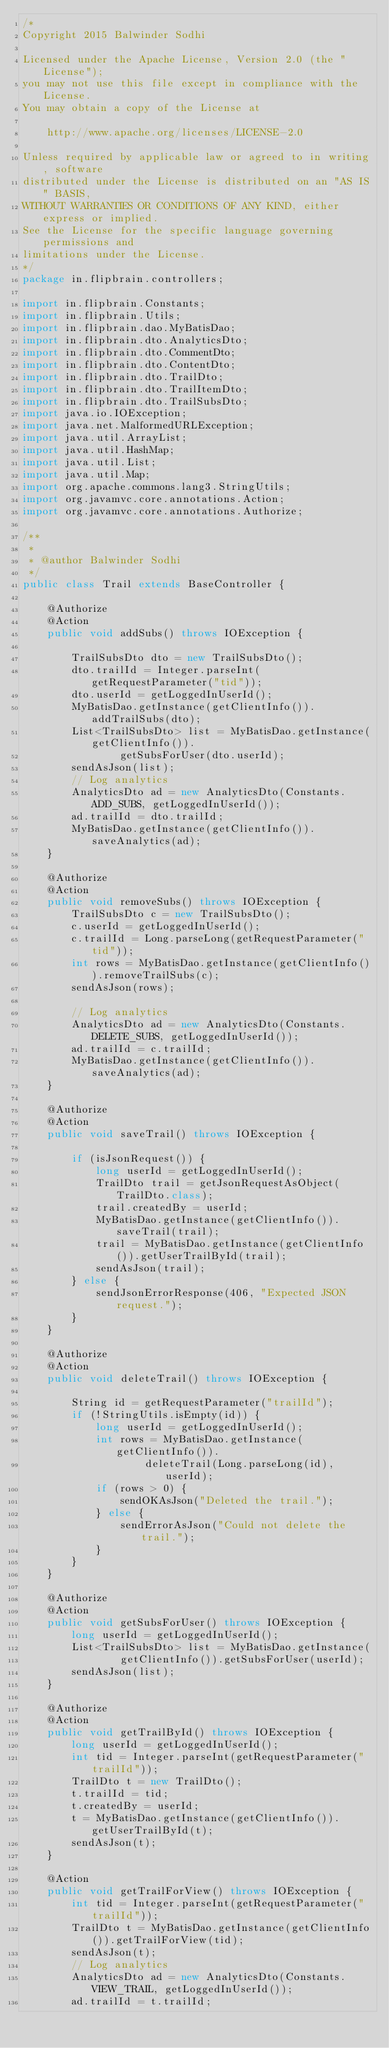<code> <loc_0><loc_0><loc_500><loc_500><_Java_>/*
Copyright 2015 Balwinder Sodhi

Licensed under the Apache License, Version 2.0 (the "License");
you may not use this file except in compliance with the License.
You may obtain a copy of the License at

    http://www.apache.org/licenses/LICENSE-2.0

Unless required by applicable law or agreed to in writing, software
distributed under the License is distributed on an "AS IS" BASIS,
WITHOUT WARRANTIES OR CONDITIONS OF ANY KIND, either express or implied.
See the License for the specific language governing permissions and
limitations under the License.
*/
package in.flipbrain.controllers;

import in.flipbrain.Constants;
import in.flipbrain.Utils;
import in.flipbrain.dao.MyBatisDao;
import in.flipbrain.dto.AnalyticsDto;
import in.flipbrain.dto.CommentDto;
import in.flipbrain.dto.ContentDto;
import in.flipbrain.dto.TrailDto;
import in.flipbrain.dto.TrailItemDto;
import in.flipbrain.dto.TrailSubsDto;
import java.io.IOException;
import java.net.MalformedURLException;
import java.util.ArrayList;
import java.util.HashMap;
import java.util.List;
import java.util.Map;
import org.apache.commons.lang3.StringUtils;
import org.javamvc.core.annotations.Action;
import org.javamvc.core.annotations.Authorize;

/**
 *
 * @author Balwinder Sodhi
 */
public class Trail extends BaseController {

    @Authorize
    @Action
    public void addSubs() throws IOException {

        TrailSubsDto dto = new TrailSubsDto();
        dto.trailId = Integer.parseInt(getRequestParameter("tid"));
        dto.userId = getLoggedInUserId();
        MyBatisDao.getInstance(getClientInfo()).addTrailSubs(dto);
        List<TrailSubsDto> list = MyBatisDao.getInstance(getClientInfo()).
                getSubsForUser(dto.userId);
        sendAsJson(list);
        // Log analytics
        AnalyticsDto ad = new AnalyticsDto(Constants.ADD_SUBS, getLoggedInUserId());
        ad.trailId = dto.trailId;
        MyBatisDao.getInstance(getClientInfo()).saveAnalytics(ad);
    }

    @Authorize
    @Action
    public void removeSubs() throws IOException {
        TrailSubsDto c = new TrailSubsDto();
        c.userId = getLoggedInUserId();
        c.trailId = Long.parseLong(getRequestParameter("tid"));
        int rows = MyBatisDao.getInstance(getClientInfo()).removeTrailSubs(c);
        sendAsJson(rows);

        // Log analytics
        AnalyticsDto ad = new AnalyticsDto(Constants.DELETE_SUBS, getLoggedInUserId());
        ad.trailId = c.trailId;
        MyBatisDao.getInstance(getClientInfo()).saveAnalytics(ad);
    }

    @Authorize
    @Action
    public void saveTrail() throws IOException {

        if (isJsonRequest()) {
            long userId = getLoggedInUserId();
            TrailDto trail = getJsonRequestAsObject(TrailDto.class);
            trail.createdBy = userId;
            MyBatisDao.getInstance(getClientInfo()).saveTrail(trail);
            trail = MyBatisDao.getInstance(getClientInfo()).getUserTrailById(trail);
            sendAsJson(trail);
        } else {
            sendJsonErrorResponse(406, "Expected JSON request.");
        }
    }

    @Authorize
    @Action
    public void deleteTrail() throws IOException {

        String id = getRequestParameter("trailId");
        if (!StringUtils.isEmpty(id)) {
            long userId = getLoggedInUserId();
            int rows = MyBatisDao.getInstance(getClientInfo()).
                    deleteTrail(Long.parseLong(id), userId);
            if (rows > 0) {
                sendOKAsJson("Deleted the trail.");
            } else {
                sendErrorAsJson("Could not delete the trail.");
            }
        }
    }

    @Authorize
    @Action
    public void getSubsForUser() throws IOException {
        long userId = getLoggedInUserId();
        List<TrailSubsDto> list = MyBatisDao.getInstance(
                getClientInfo()).getSubsForUser(userId);
        sendAsJson(list);
    }

    @Authorize
    @Action
    public void getTrailById() throws IOException {
        long userId = getLoggedInUserId();
        int tid = Integer.parseInt(getRequestParameter("trailId"));
        TrailDto t = new TrailDto();
        t.trailId = tid;
        t.createdBy = userId;
        t = MyBatisDao.getInstance(getClientInfo()).getUserTrailById(t);
        sendAsJson(t);
    }

    @Action
    public void getTrailForView() throws IOException {
        int tid = Integer.parseInt(getRequestParameter("trailId"));
        TrailDto t = MyBatisDao.getInstance(getClientInfo()).getTrailForView(tid);
        sendAsJson(t);
        // Log analytics
        AnalyticsDto ad = new AnalyticsDto(Constants.VIEW_TRAIL, getLoggedInUserId());
        ad.trailId = t.trailId;</code> 